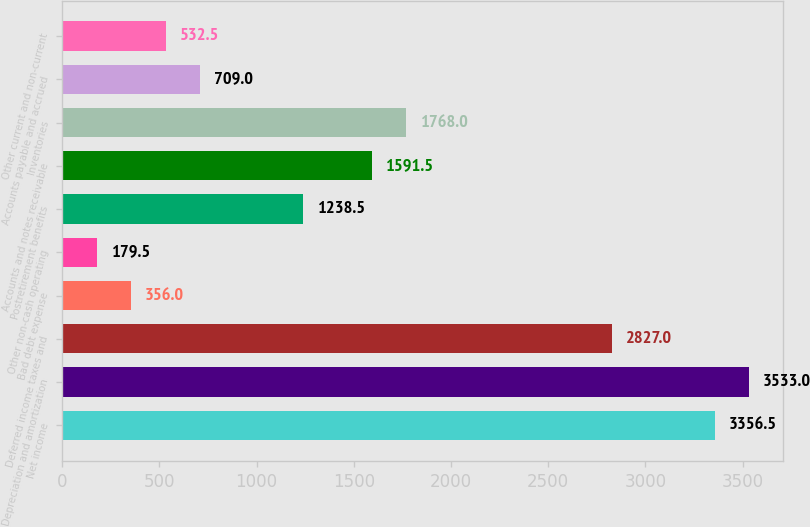Convert chart. <chart><loc_0><loc_0><loc_500><loc_500><bar_chart><fcel>Net income<fcel>Depreciation and amortization<fcel>Deferred income taxes and<fcel>Bad debt expense<fcel>Other non-cash operating<fcel>Postretirement benefits<fcel>Accounts and notes receivable<fcel>Inventories<fcel>Accounts payable and accrued<fcel>Other current and non-current<nl><fcel>3356.5<fcel>3533<fcel>2827<fcel>356<fcel>179.5<fcel>1238.5<fcel>1591.5<fcel>1768<fcel>709<fcel>532.5<nl></chart> 